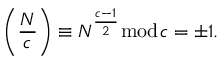Convert formula to latex. <formula><loc_0><loc_0><loc_500><loc_500>\left ( { \frac { N } { c } } \right ) \equiv N ^ { \frac { c - 1 } { 2 } } { \bmod { c } } = \pm 1 .</formula> 